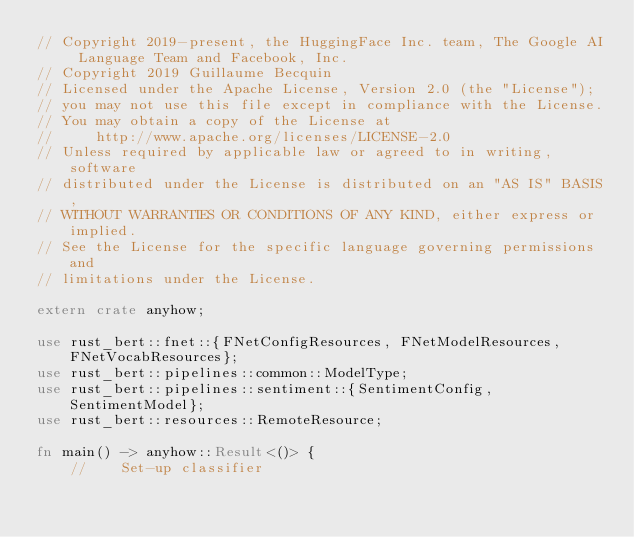Convert code to text. <code><loc_0><loc_0><loc_500><loc_500><_Rust_>// Copyright 2019-present, the HuggingFace Inc. team, The Google AI Language Team and Facebook, Inc.
// Copyright 2019 Guillaume Becquin
// Licensed under the Apache License, Version 2.0 (the "License");
// you may not use this file except in compliance with the License.
// You may obtain a copy of the License at
//     http://www.apache.org/licenses/LICENSE-2.0
// Unless required by applicable law or agreed to in writing, software
// distributed under the License is distributed on an "AS IS" BASIS,
// WITHOUT WARRANTIES OR CONDITIONS OF ANY KIND, either express or implied.
// See the License for the specific language governing permissions and
// limitations under the License.

extern crate anyhow;

use rust_bert::fnet::{FNetConfigResources, FNetModelResources, FNetVocabResources};
use rust_bert::pipelines::common::ModelType;
use rust_bert::pipelines::sentiment::{SentimentConfig, SentimentModel};
use rust_bert::resources::RemoteResource;

fn main() -> anyhow::Result<()> {
    //    Set-up classifier</code> 